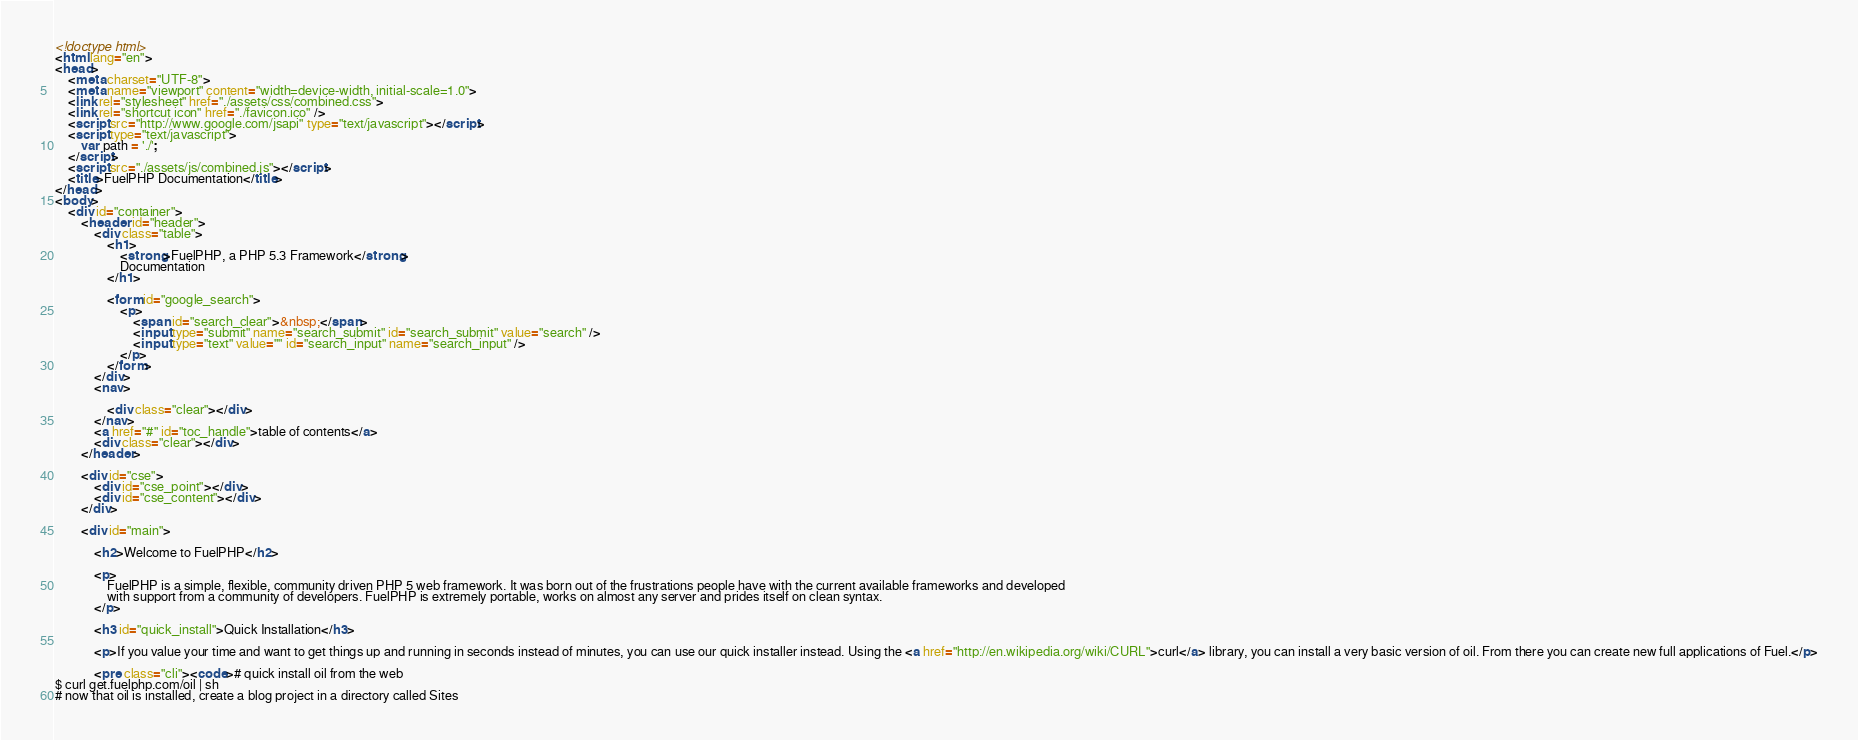<code> <loc_0><loc_0><loc_500><loc_500><_HTML_><!doctype html>
<html lang="en">
<head>
	<meta charset="UTF-8">
	<meta name="viewport" content="width=device-width, initial-scale=1.0">
	<link rel="stylesheet" href="./assets/css/combined.css">
	<link rel="shortcut icon" href="./favicon.ico" />
 	<script src="http://www.google.com/jsapi" type="text/javascript"></script>
	<script type="text/javascript">
		var path = './';
	</script>
	<script src="./assets/js/combined.js"></script>
	<title>FuelPHP Documentation</title>
</head>
<body>
	<div id="container">
		<header id="header">
			<div class="table">
				<h1>
					<strong>FuelPHP, a PHP 5.3 Framework</strong>
					Documentation
				</h1>

				<form id="google_search">
					<p>
						<span id="search_clear">&nbsp;</span>
						<input type="submit" name="search_submit" id="search_submit" value="search" />
						<input type="text" value="" id="search_input" name="search_input" />
					</p>
				</form>
			</div>
			<nav>

				<div class="clear"></div>
			</nav>
			<a href="#" id="toc_handle">table of contents</a>
			<div class="clear"></div>
		</header>

		<div id="cse">
			<div id="cse_point"></div>
			<div id="cse_content"></div>
		</div>

		<div id="main">

			<h2>Welcome to FuelPHP</h2>

			<p>
				FuelPHP is a simple, flexible, community driven PHP 5 web framework. It was born out of the frustrations people have with the current available frameworks and developed
				with support from a community of developers. FuelPHP is extremely portable, works on almost any server and prides itself on clean syntax.
			</p>

			<h3 id="quick_install">Quick Installation</h3>

			<p>If you value your time and want to get things up and running in seconds instead of minutes, you can use our quick installer instead. Using the <a href="http://en.wikipedia.org/wiki/CURL">curl</a> library, you can install a very basic version of oil. From there you can create new full applications of Fuel.</p>

			<pre class="cli"><code># quick install oil from the web
$ curl get.fuelphp.com/oil | sh
# now that oil is installed, create a blog project in a directory called Sites</code> 